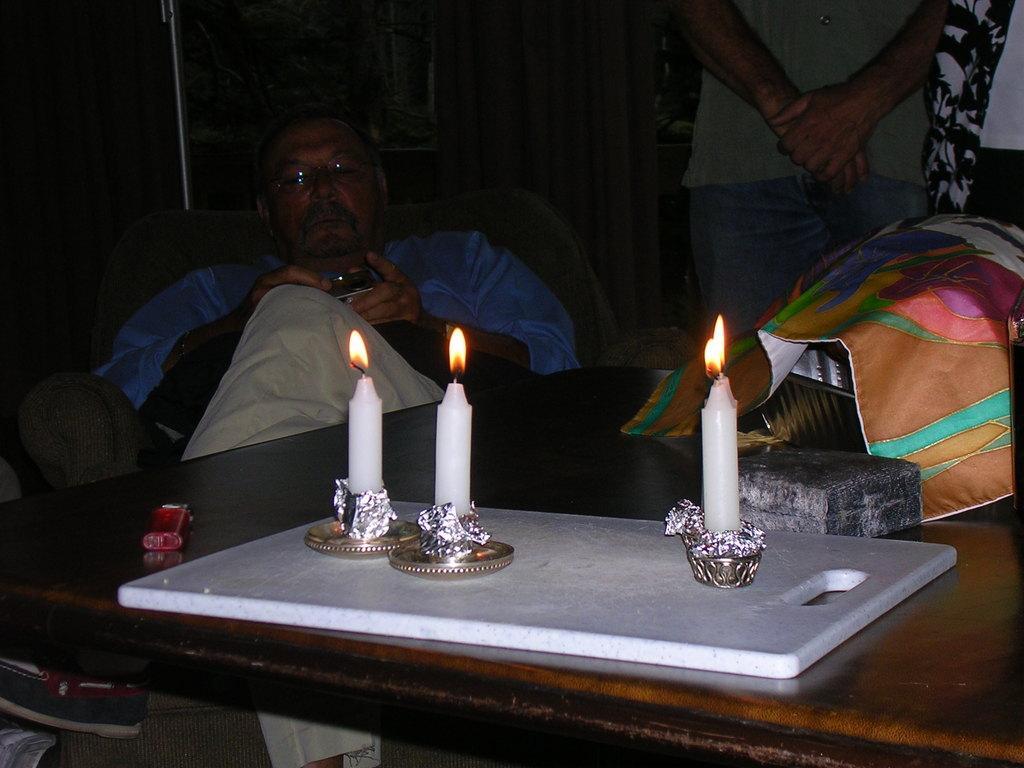In one or two sentences, can you explain what this image depicts? Here we can see a person sitting on a chair and beside him we can see a person standing and in front of them we can see a table having candles on it and we can see some things present on table 